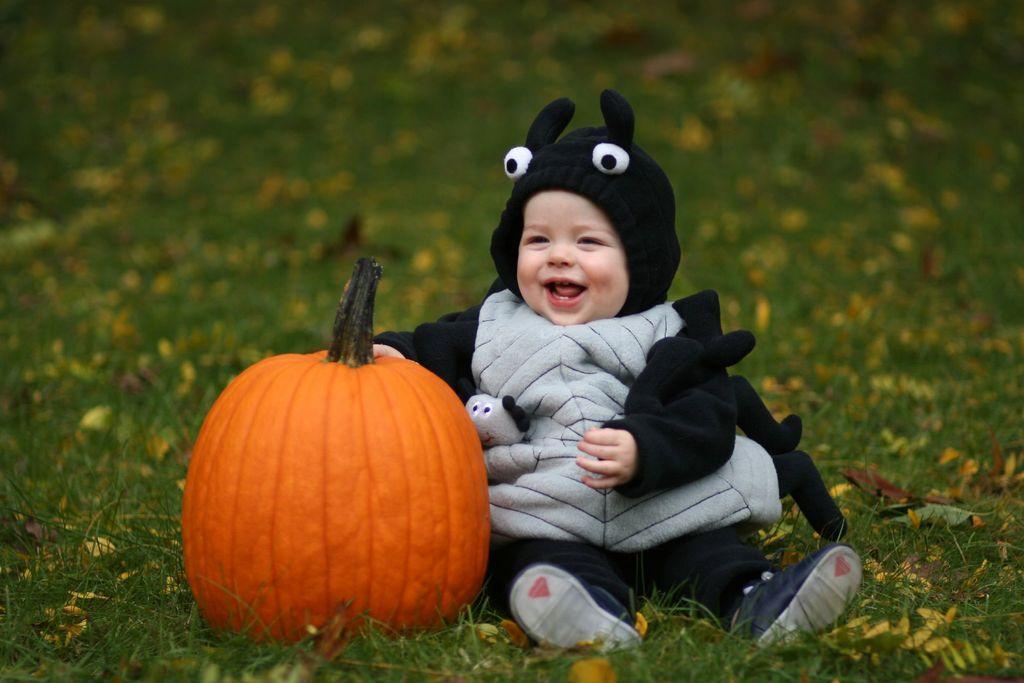How would you summarize this image in a sentence or two? In this picture there is a kid wearing fancy dress is sitting on a greenery ground and there is a pumpkin which is in orange color is beside him. 